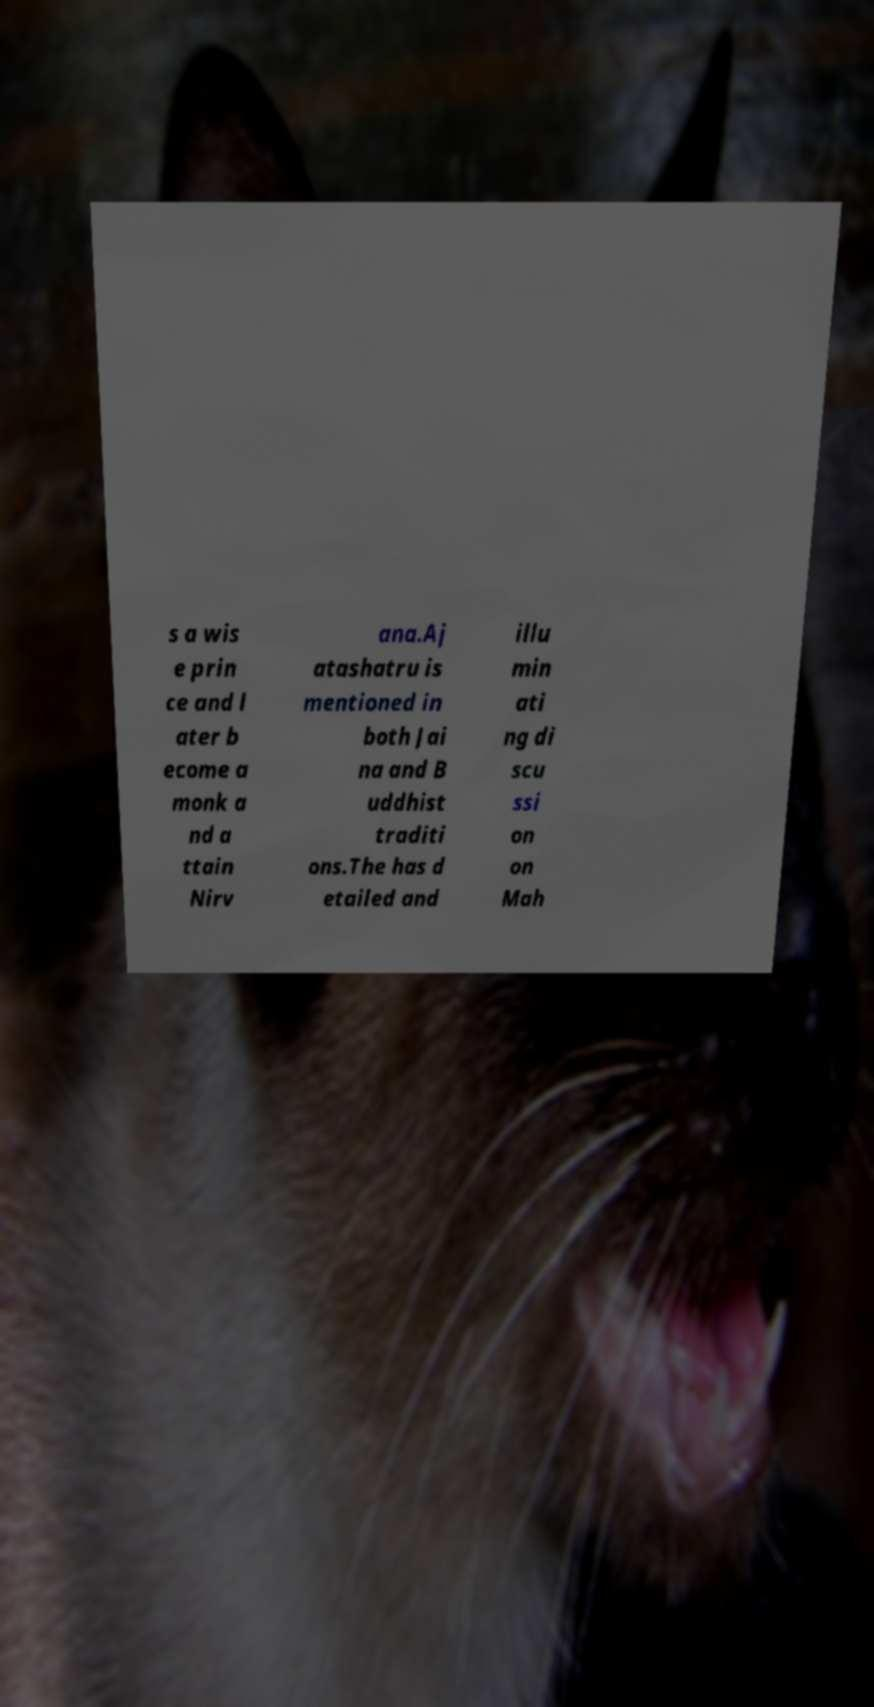Can you accurately transcribe the text from the provided image for me? s a wis e prin ce and l ater b ecome a monk a nd a ttain Nirv ana.Aj atashatru is mentioned in both Jai na and B uddhist traditi ons.The has d etailed and illu min ati ng di scu ssi on on Mah 